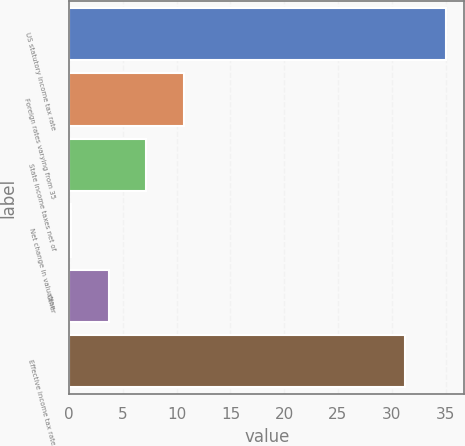<chart> <loc_0><loc_0><loc_500><loc_500><bar_chart><fcel>US statutory income tax rate<fcel>Foreign rates varying from 35<fcel>State income taxes net of<fcel>Net change in valuation<fcel>Other<fcel>Effective income tax rate<nl><fcel>35<fcel>10.64<fcel>7.16<fcel>0.2<fcel>3.68<fcel>31.2<nl></chart> 